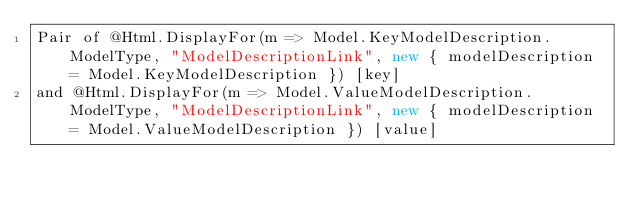Convert code to text. <code><loc_0><loc_0><loc_500><loc_500><_C#_>Pair of @Html.DisplayFor(m => Model.KeyModelDescription.ModelType, "ModelDescriptionLink", new { modelDescription = Model.KeyModelDescription }) [key]
and @Html.DisplayFor(m => Model.ValueModelDescription.ModelType, "ModelDescriptionLink", new { modelDescription = Model.ValueModelDescription }) [value]</code> 